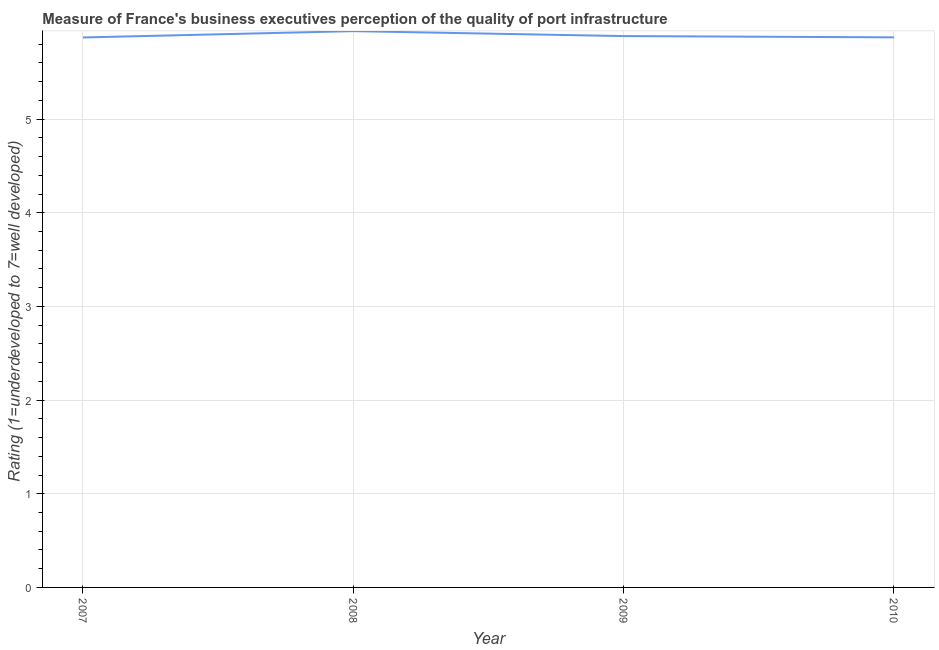What is the rating measuring quality of port infrastructure in 2009?
Ensure brevity in your answer.  5.89. Across all years, what is the maximum rating measuring quality of port infrastructure?
Offer a terse response. 5.94. Across all years, what is the minimum rating measuring quality of port infrastructure?
Offer a terse response. 5.87. In which year was the rating measuring quality of port infrastructure minimum?
Give a very brief answer. 2007. What is the sum of the rating measuring quality of port infrastructure?
Provide a succinct answer. 23.57. What is the difference between the rating measuring quality of port infrastructure in 2007 and 2010?
Keep it short and to the point. -0. What is the average rating measuring quality of port infrastructure per year?
Your response must be concise. 5.89. What is the median rating measuring quality of port infrastructure?
Your answer should be compact. 5.88. What is the ratio of the rating measuring quality of port infrastructure in 2008 to that in 2010?
Provide a succinct answer. 1.01. Is the rating measuring quality of port infrastructure in 2007 less than that in 2008?
Make the answer very short. Yes. Is the difference between the rating measuring quality of port infrastructure in 2009 and 2010 greater than the difference between any two years?
Offer a terse response. No. What is the difference between the highest and the second highest rating measuring quality of port infrastructure?
Your response must be concise. 0.05. What is the difference between the highest and the lowest rating measuring quality of port infrastructure?
Provide a succinct answer. 0.07. How many lines are there?
Make the answer very short. 1. Are the values on the major ticks of Y-axis written in scientific E-notation?
Provide a succinct answer. No. Does the graph contain any zero values?
Ensure brevity in your answer.  No. Does the graph contain grids?
Your response must be concise. Yes. What is the title of the graph?
Keep it short and to the point. Measure of France's business executives perception of the quality of port infrastructure. What is the label or title of the X-axis?
Your answer should be very brief. Year. What is the label or title of the Y-axis?
Provide a short and direct response. Rating (1=underdeveloped to 7=well developed) . What is the Rating (1=underdeveloped to 7=well developed)  in 2007?
Your answer should be compact. 5.87. What is the Rating (1=underdeveloped to 7=well developed)  of 2008?
Provide a short and direct response. 5.94. What is the Rating (1=underdeveloped to 7=well developed)  in 2009?
Your answer should be very brief. 5.89. What is the Rating (1=underdeveloped to 7=well developed)  in 2010?
Offer a very short reply. 5.87. What is the difference between the Rating (1=underdeveloped to 7=well developed)  in 2007 and 2008?
Your response must be concise. -0.07. What is the difference between the Rating (1=underdeveloped to 7=well developed)  in 2007 and 2009?
Make the answer very short. -0.01. What is the difference between the Rating (1=underdeveloped to 7=well developed)  in 2007 and 2010?
Provide a short and direct response. -0. What is the difference between the Rating (1=underdeveloped to 7=well developed)  in 2008 and 2009?
Make the answer very short. 0.05. What is the difference between the Rating (1=underdeveloped to 7=well developed)  in 2008 and 2010?
Give a very brief answer. 0.07. What is the difference between the Rating (1=underdeveloped to 7=well developed)  in 2009 and 2010?
Offer a very short reply. 0.01. What is the ratio of the Rating (1=underdeveloped to 7=well developed)  in 2007 to that in 2008?
Give a very brief answer. 0.99. What is the ratio of the Rating (1=underdeveloped to 7=well developed)  in 2007 to that in 2010?
Ensure brevity in your answer.  1. What is the ratio of the Rating (1=underdeveloped to 7=well developed)  in 2008 to that in 2009?
Your answer should be compact. 1.01. What is the ratio of the Rating (1=underdeveloped to 7=well developed)  in 2008 to that in 2010?
Make the answer very short. 1.01. 